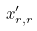Convert formula to latex. <formula><loc_0><loc_0><loc_500><loc_500>x _ { r , r } ^ { \prime }</formula> 